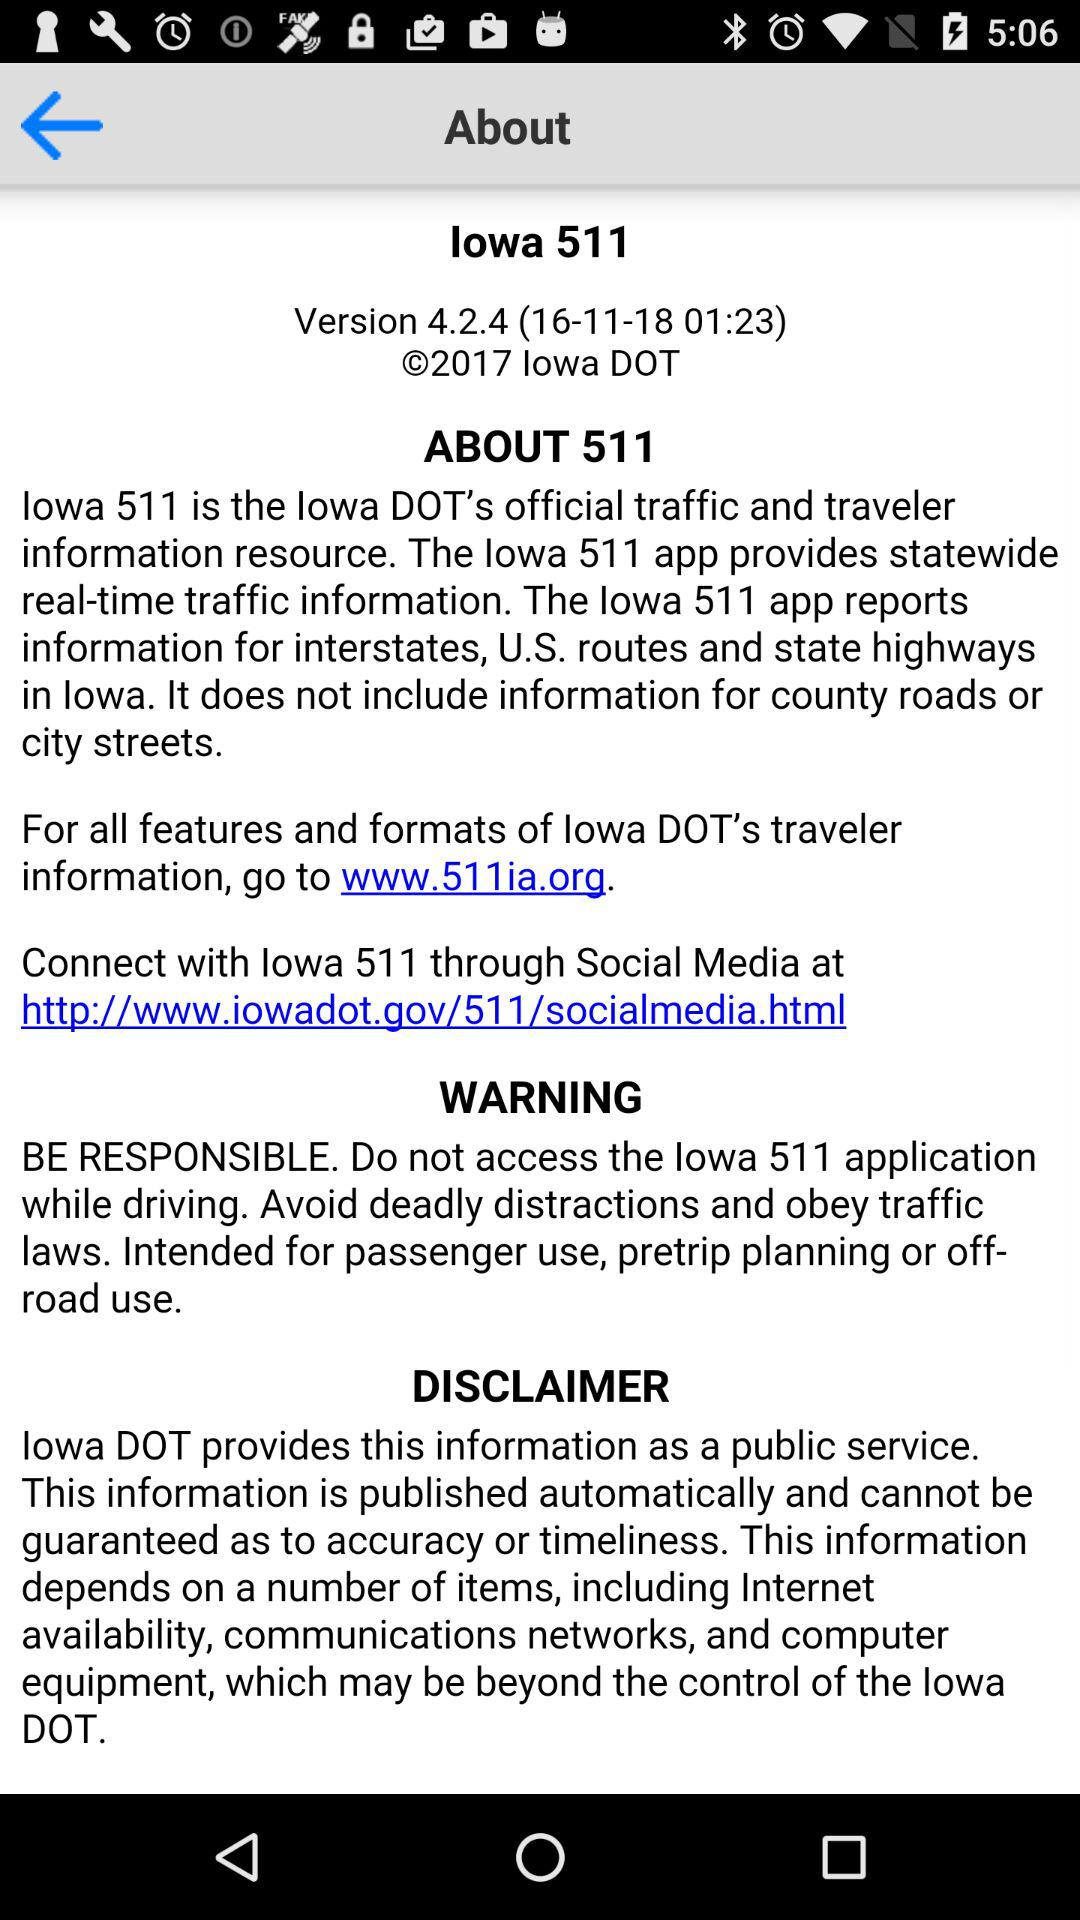How many links are there to external websites?
Answer the question using a single word or phrase. 2 